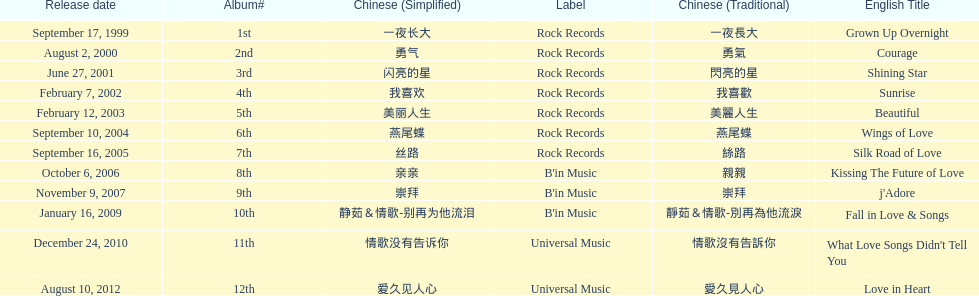Which song is listed first in the table? Grown Up Overnight. 